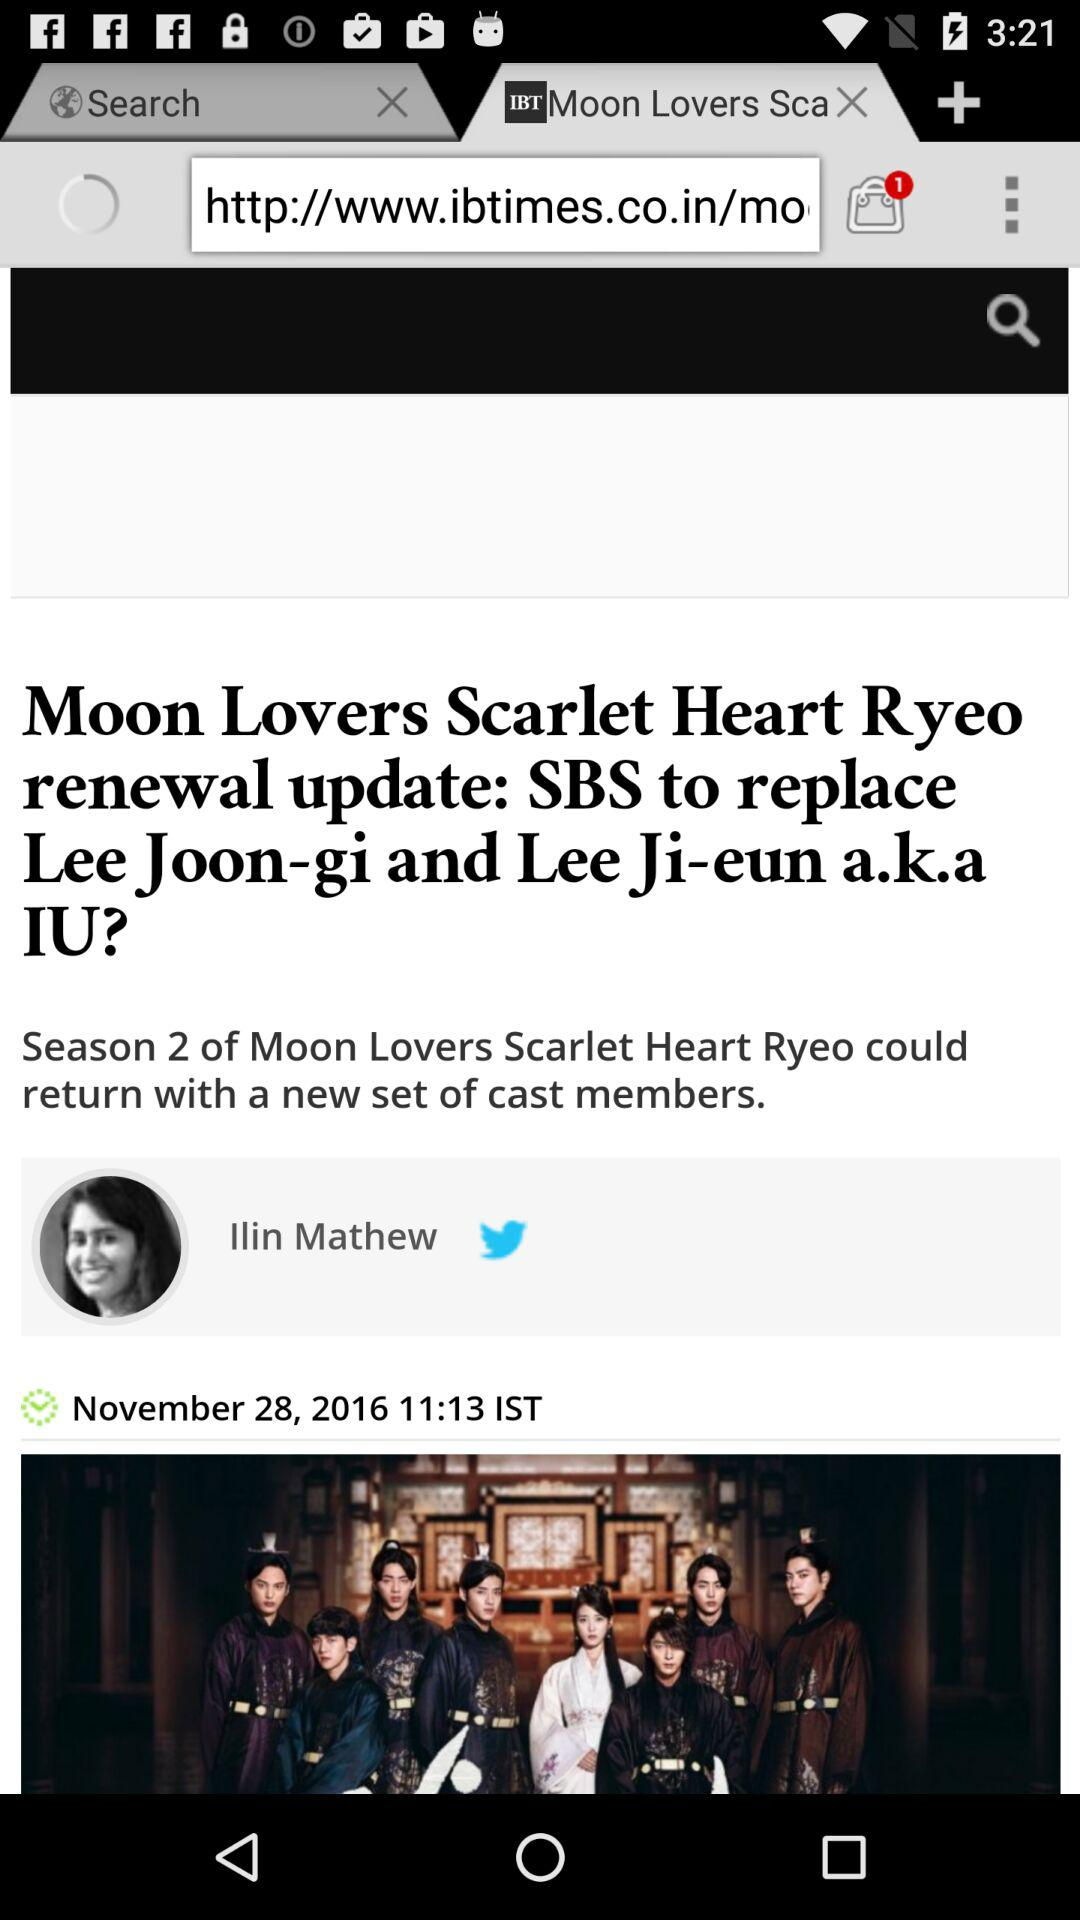What is the title of the content? The title of the content is "Moon Lovers Scarlet Heart Ryeo renewal update: SBS to replace Lee Joon-gi and Lee Ji-eun a.k.a IU?". 